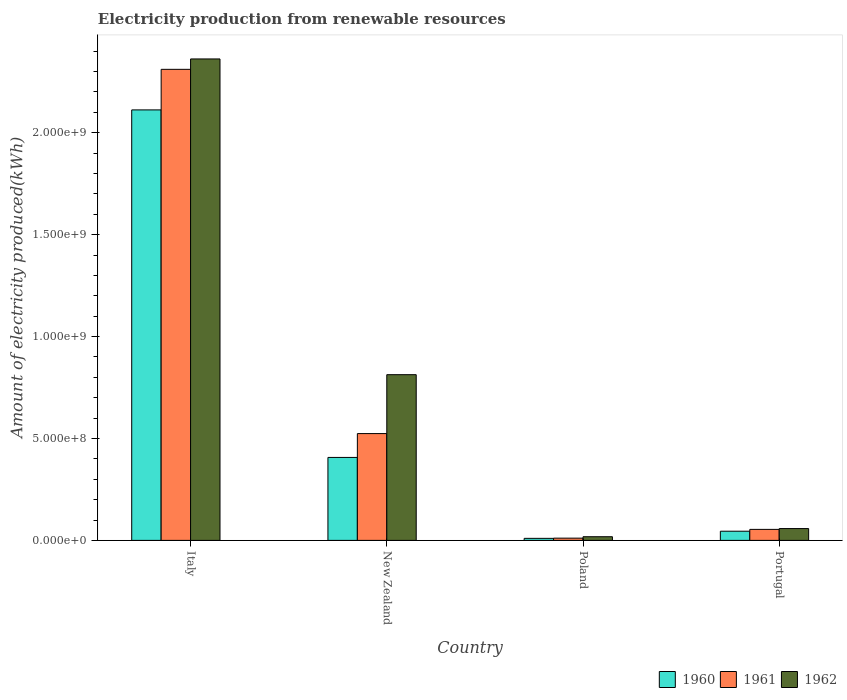How many different coloured bars are there?
Offer a very short reply. 3. How many groups of bars are there?
Your answer should be very brief. 4. Are the number of bars per tick equal to the number of legend labels?
Give a very brief answer. Yes. How many bars are there on the 2nd tick from the right?
Your answer should be compact. 3. What is the label of the 2nd group of bars from the left?
Your answer should be compact. New Zealand. In how many cases, is the number of bars for a given country not equal to the number of legend labels?
Offer a terse response. 0. What is the amount of electricity produced in 1960 in Poland?
Provide a succinct answer. 1.00e+07. Across all countries, what is the maximum amount of electricity produced in 1961?
Provide a short and direct response. 2.31e+09. Across all countries, what is the minimum amount of electricity produced in 1962?
Make the answer very short. 1.80e+07. In which country was the amount of electricity produced in 1962 maximum?
Give a very brief answer. Italy. What is the total amount of electricity produced in 1961 in the graph?
Provide a succinct answer. 2.90e+09. What is the difference between the amount of electricity produced in 1961 in Poland and that in Portugal?
Your response must be concise. -4.30e+07. What is the difference between the amount of electricity produced in 1961 in Portugal and the amount of electricity produced in 1960 in Italy?
Offer a very short reply. -2.06e+09. What is the average amount of electricity produced in 1962 per country?
Offer a terse response. 8.13e+08. What is the difference between the amount of electricity produced of/in 1961 and amount of electricity produced of/in 1962 in New Zealand?
Keep it short and to the point. -2.89e+08. What is the ratio of the amount of electricity produced in 1961 in Poland to that in Portugal?
Keep it short and to the point. 0.2. Is the difference between the amount of electricity produced in 1961 in New Zealand and Portugal greater than the difference between the amount of electricity produced in 1962 in New Zealand and Portugal?
Your answer should be compact. No. What is the difference between the highest and the second highest amount of electricity produced in 1960?
Keep it short and to the point. 2.07e+09. What is the difference between the highest and the lowest amount of electricity produced in 1960?
Provide a succinct answer. 2.10e+09. In how many countries, is the amount of electricity produced in 1961 greater than the average amount of electricity produced in 1961 taken over all countries?
Provide a succinct answer. 1. Is the sum of the amount of electricity produced in 1962 in Poland and Portugal greater than the maximum amount of electricity produced in 1960 across all countries?
Offer a terse response. No. Is it the case that in every country, the sum of the amount of electricity produced in 1962 and amount of electricity produced in 1961 is greater than the amount of electricity produced in 1960?
Provide a short and direct response. Yes. How many bars are there?
Keep it short and to the point. 12. What is the difference between two consecutive major ticks on the Y-axis?
Ensure brevity in your answer.  5.00e+08. Are the values on the major ticks of Y-axis written in scientific E-notation?
Offer a very short reply. Yes. Does the graph contain any zero values?
Offer a very short reply. No. Does the graph contain grids?
Make the answer very short. No. Where does the legend appear in the graph?
Keep it short and to the point. Bottom right. How are the legend labels stacked?
Offer a very short reply. Horizontal. What is the title of the graph?
Your answer should be very brief. Electricity production from renewable resources. Does "1998" appear as one of the legend labels in the graph?
Provide a succinct answer. No. What is the label or title of the Y-axis?
Your response must be concise. Amount of electricity produced(kWh). What is the Amount of electricity produced(kWh) in 1960 in Italy?
Your answer should be very brief. 2.11e+09. What is the Amount of electricity produced(kWh) of 1961 in Italy?
Keep it short and to the point. 2.31e+09. What is the Amount of electricity produced(kWh) of 1962 in Italy?
Make the answer very short. 2.36e+09. What is the Amount of electricity produced(kWh) in 1960 in New Zealand?
Ensure brevity in your answer.  4.07e+08. What is the Amount of electricity produced(kWh) in 1961 in New Zealand?
Ensure brevity in your answer.  5.24e+08. What is the Amount of electricity produced(kWh) of 1962 in New Zealand?
Make the answer very short. 8.13e+08. What is the Amount of electricity produced(kWh) in 1960 in Poland?
Provide a succinct answer. 1.00e+07. What is the Amount of electricity produced(kWh) in 1961 in Poland?
Give a very brief answer. 1.10e+07. What is the Amount of electricity produced(kWh) of 1962 in Poland?
Your response must be concise. 1.80e+07. What is the Amount of electricity produced(kWh) of 1960 in Portugal?
Offer a terse response. 4.50e+07. What is the Amount of electricity produced(kWh) in 1961 in Portugal?
Ensure brevity in your answer.  5.40e+07. What is the Amount of electricity produced(kWh) of 1962 in Portugal?
Your response must be concise. 5.80e+07. Across all countries, what is the maximum Amount of electricity produced(kWh) of 1960?
Make the answer very short. 2.11e+09. Across all countries, what is the maximum Amount of electricity produced(kWh) of 1961?
Provide a succinct answer. 2.31e+09. Across all countries, what is the maximum Amount of electricity produced(kWh) in 1962?
Offer a very short reply. 2.36e+09. Across all countries, what is the minimum Amount of electricity produced(kWh) of 1960?
Ensure brevity in your answer.  1.00e+07. Across all countries, what is the minimum Amount of electricity produced(kWh) of 1961?
Your answer should be very brief. 1.10e+07. Across all countries, what is the minimum Amount of electricity produced(kWh) in 1962?
Provide a succinct answer. 1.80e+07. What is the total Amount of electricity produced(kWh) of 1960 in the graph?
Ensure brevity in your answer.  2.57e+09. What is the total Amount of electricity produced(kWh) of 1961 in the graph?
Offer a terse response. 2.90e+09. What is the total Amount of electricity produced(kWh) of 1962 in the graph?
Your answer should be very brief. 3.25e+09. What is the difference between the Amount of electricity produced(kWh) of 1960 in Italy and that in New Zealand?
Your response must be concise. 1.70e+09. What is the difference between the Amount of electricity produced(kWh) in 1961 in Italy and that in New Zealand?
Offer a terse response. 1.79e+09. What is the difference between the Amount of electricity produced(kWh) in 1962 in Italy and that in New Zealand?
Keep it short and to the point. 1.55e+09. What is the difference between the Amount of electricity produced(kWh) of 1960 in Italy and that in Poland?
Your answer should be compact. 2.10e+09. What is the difference between the Amount of electricity produced(kWh) in 1961 in Italy and that in Poland?
Provide a short and direct response. 2.30e+09. What is the difference between the Amount of electricity produced(kWh) of 1962 in Italy and that in Poland?
Ensure brevity in your answer.  2.34e+09. What is the difference between the Amount of electricity produced(kWh) in 1960 in Italy and that in Portugal?
Offer a terse response. 2.07e+09. What is the difference between the Amount of electricity produced(kWh) in 1961 in Italy and that in Portugal?
Make the answer very short. 2.26e+09. What is the difference between the Amount of electricity produced(kWh) in 1962 in Italy and that in Portugal?
Make the answer very short. 2.30e+09. What is the difference between the Amount of electricity produced(kWh) in 1960 in New Zealand and that in Poland?
Keep it short and to the point. 3.97e+08. What is the difference between the Amount of electricity produced(kWh) in 1961 in New Zealand and that in Poland?
Give a very brief answer. 5.13e+08. What is the difference between the Amount of electricity produced(kWh) of 1962 in New Zealand and that in Poland?
Your answer should be compact. 7.95e+08. What is the difference between the Amount of electricity produced(kWh) of 1960 in New Zealand and that in Portugal?
Your answer should be very brief. 3.62e+08. What is the difference between the Amount of electricity produced(kWh) in 1961 in New Zealand and that in Portugal?
Make the answer very short. 4.70e+08. What is the difference between the Amount of electricity produced(kWh) in 1962 in New Zealand and that in Portugal?
Ensure brevity in your answer.  7.55e+08. What is the difference between the Amount of electricity produced(kWh) of 1960 in Poland and that in Portugal?
Keep it short and to the point. -3.50e+07. What is the difference between the Amount of electricity produced(kWh) in 1961 in Poland and that in Portugal?
Provide a succinct answer. -4.30e+07. What is the difference between the Amount of electricity produced(kWh) in 1962 in Poland and that in Portugal?
Your answer should be very brief. -4.00e+07. What is the difference between the Amount of electricity produced(kWh) in 1960 in Italy and the Amount of electricity produced(kWh) in 1961 in New Zealand?
Offer a very short reply. 1.59e+09. What is the difference between the Amount of electricity produced(kWh) in 1960 in Italy and the Amount of electricity produced(kWh) in 1962 in New Zealand?
Provide a succinct answer. 1.30e+09. What is the difference between the Amount of electricity produced(kWh) of 1961 in Italy and the Amount of electricity produced(kWh) of 1962 in New Zealand?
Provide a short and direct response. 1.50e+09. What is the difference between the Amount of electricity produced(kWh) of 1960 in Italy and the Amount of electricity produced(kWh) of 1961 in Poland?
Your response must be concise. 2.10e+09. What is the difference between the Amount of electricity produced(kWh) in 1960 in Italy and the Amount of electricity produced(kWh) in 1962 in Poland?
Offer a very short reply. 2.09e+09. What is the difference between the Amount of electricity produced(kWh) of 1961 in Italy and the Amount of electricity produced(kWh) of 1962 in Poland?
Your answer should be very brief. 2.29e+09. What is the difference between the Amount of electricity produced(kWh) in 1960 in Italy and the Amount of electricity produced(kWh) in 1961 in Portugal?
Keep it short and to the point. 2.06e+09. What is the difference between the Amount of electricity produced(kWh) in 1960 in Italy and the Amount of electricity produced(kWh) in 1962 in Portugal?
Your answer should be compact. 2.05e+09. What is the difference between the Amount of electricity produced(kWh) in 1961 in Italy and the Amount of electricity produced(kWh) in 1962 in Portugal?
Keep it short and to the point. 2.25e+09. What is the difference between the Amount of electricity produced(kWh) of 1960 in New Zealand and the Amount of electricity produced(kWh) of 1961 in Poland?
Provide a short and direct response. 3.96e+08. What is the difference between the Amount of electricity produced(kWh) in 1960 in New Zealand and the Amount of electricity produced(kWh) in 1962 in Poland?
Ensure brevity in your answer.  3.89e+08. What is the difference between the Amount of electricity produced(kWh) in 1961 in New Zealand and the Amount of electricity produced(kWh) in 1962 in Poland?
Keep it short and to the point. 5.06e+08. What is the difference between the Amount of electricity produced(kWh) of 1960 in New Zealand and the Amount of electricity produced(kWh) of 1961 in Portugal?
Keep it short and to the point. 3.53e+08. What is the difference between the Amount of electricity produced(kWh) in 1960 in New Zealand and the Amount of electricity produced(kWh) in 1962 in Portugal?
Provide a succinct answer. 3.49e+08. What is the difference between the Amount of electricity produced(kWh) of 1961 in New Zealand and the Amount of electricity produced(kWh) of 1962 in Portugal?
Ensure brevity in your answer.  4.66e+08. What is the difference between the Amount of electricity produced(kWh) in 1960 in Poland and the Amount of electricity produced(kWh) in 1961 in Portugal?
Offer a terse response. -4.40e+07. What is the difference between the Amount of electricity produced(kWh) of 1960 in Poland and the Amount of electricity produced(kWh) of 1962 in Portugal?
Your response must be concise. -4.80e+07. What is the difference between the Amount of electricity produced(kWh) in 1961 in Poland and the Amount of electricity produced(kWh) in 1962 in Portugal?
Provide a short and direct response. -4.70e+07. What is the average Amount of electricity produced(kWh) of 1960 per country?
Offer a terse response. 6.44e+08. What is the average Amount of electricity produced(kWh) in 1961 per country?
Offer a very short reply. 7.25e+08. What is the average Amount of electricity produced(kWh) of 1962 per country?
Keep it short and to the point. 8.13e+08. What is the difference between the Amount of electricity produced(kWh) in 1960 and Amount of electricity produced(kWh) in 1961 in Italy?
Your response must be concise. -1.99e+08. What is the difference between the Amount of electricity produced(kWh) in 1960 and Amount of electricity produced(kWh) in 1962 in Italy?
Provide a short and direct response. -2.50e+08. What is the difference between the Amount of electricity produced(kWh) in 1961 and Amount of electricity produced(kWh) in 1962 in Italy?
Give a very brief answer. -5.10e+07. What is the difference between the Amount of electricity produced(kWh) of 1960 and Amount of electricity produced(kWh) of 1961 in New Zealand?
Offer a very short reply. -1.17e+08. What is the difference between the Amount of electricity produced(kWh) of 1960 and Amount of electricity produced(kWh) of 1962 in New Zealand?
Make the answer very short. -4.06e+08. What is the difference between the Amount of electricity produced(kWh) of 1961 and Amount of electricity produced(kWh) of 1962 in New Zealand?
Give a very brief answer. -2.89e+08. What is the difference between the Amount of electricity produced(kWh) in 1960 and Amount of electricity produced(kWh) in 1961 in Poland?
Give a very brief answer. -1.00e+06. What is the difference between the Amount of electricity produced(kWh) of 1960 and Amount of electricity produced(kWh) of 1962 in Poland?
Keep it short and to the point. -8.00e+06. What is the difference between the Amount of electricity produced(kWh) of 1961 and Amount of electricity produced(kWh) of 1962 in Poland?
Keep it short and to the point. -7.00e+06. What is the difference between the Amount of electricity produced(kWh) of 1960 and Amount of electricity produced(kWh) of 1961 in Portugal?
Your response must be concise. -9.00e+06. What is the difference between the Amount of electricity produced(kWh) in 1960 and Amount of electricity produced(kWh) in 1962 in Portugal?
Keep it short and to the point. -1.30e+07. What is the difference between the Amount of electricity produced(kWh) in 1961 and Amount of electricity produced(kWh) in 1962 in Portugal?
Your answer should be compact. -4.00e+06. What is the ratio of the Amount of electricity produced(kWh) in 1960 in Italy to that in New Zealand?
Your answer should be very brief. 5.19. What is the ratio of the Amount of electricity produced(kWh) in 1961 in Italy to that in New Zealand?
Provide a short and direct response. 4.41. What is the ratio of the Amount of electricity produced(kWh) in 1962 in Italy to that in New Zealand?
Ensure brevity in your answer.  2.91. What is the ratio of the Amount of electricity produced(kWh) in 1960 in Italy to that in Poland?
Offer a very short reply. 211.2. What is the ratio of the Amount of electricity produced(kWh) of 1961 in Italy to that in Poland?
Give a very brief answer. 210.09. What is the ratio of the Amount of electricity produced(kWh) in 1962 in Italy to that in Poland?
Provide a short and direct response. 131.22. What is the ratio of the Amount of electricity produced(kWh) in 1960 in Italy to that in Portugal?
Offer a very short reply. 46.93. What is the ratio of the Amount of electricity produced(kWh) in 1961 in Italy to that in Portugal?
Offer a terse response. 42.8. What is the ratio of the Amount of electricity produced(kWh) in 1962 in Italy to that in Portugal?
Provide a succinct answer. 40.72. What is the ratio of the Amount of electricity produced(kWh) in 1960 in New Zealand to that in Poland?
Offer a very short reply. 40.7. What is the ratio of the Amount of electricity produced(kWh) of 1961 in New Zealand to that in Poland?
Keep it short and to the point. 47.64. What is the ratio of the Amount of electricity produced(kWh) in 1962 in New Zealand to that in Poland?
Your answer should be very brief. 45.17. What is the ratio of the Amount of electricity produced(kWh) of 1960 in New Zealand to that in Portugal?
Offer a terse response. 9.04. What is the ratio of the Amount of electricity produced(kWh) of 1961 in New Zealand to that in Portugal?
Provide a short and direct response. 9.7. What is the ratio of the Amount of electricity produced(kWh) of 1962 in New Zealand to that in Portugal?
Make the answer very short. 14.02. What is the ratio of the Amount of electricity produced(kWh) of 1960 in Poland to that in Portugal?
Offer a very short reply. 0.22. What is the ratio of the Amount of electricity produced(kWh) of 1961 in Poland to that in Portugal?
Ensure brevity in your answer.  0.2. What is the ratio of the Amount of electricity produced(kWh) in 1962 in Poland to that in Portugal?
Provide a succinct answer. 0.31. What is the difference between the highest and the second highest Amount of electricity produced(kWh) in 1960?
Keep it short and to the point. 1.70e+09. What is the difference between the highest and the second highest Amount of electricity produced(kWh) of 1961?
Your answer should be very brief. 1.79e+09. What is the difference between the highest and the second highest Amount of electricity produced(kWh) of 1962?
Your response must be concise. 1.55e+09. What is the difference between the highest and the lowest Amount of electricity produced(kWh) of 1960?
Provide a succinct answer. 2.10e+09. What is the difference between the highest and the lowest Amount of electricity produced(kWh) in 1961?
Give a very brief answer. 2.30e+09. What is the difference between the highest and the lowest Amount of electricity produced(kWh) in 1962?
Provide a succinct answer. 2.34e+09. 